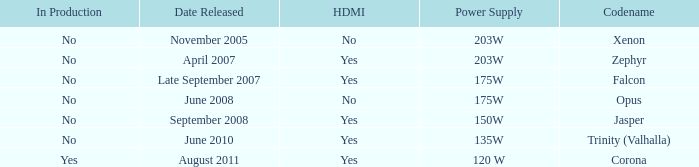Is Jasper being producted? No. 